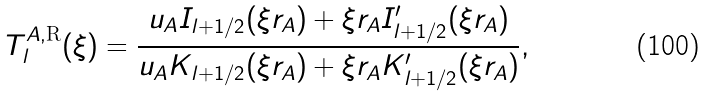Convert formula to latex. <formula><loc_0><loc_0><loc_500><loc_500>T ^ { A , \text {R} } _ { l } ( \xi ) = \frac { u _ { A } I _ { l + 1 / 2 } ( \xi r _ { A } ) + \xi r _ { A } I _ { l + 1 / 2 } ^ { \prime } ( \xi r _ { A } ) } { u _ { A } K _ { l + 1 / 2 } ( \xi r _ { A } ) + \xi r _ { A } K _ { l + 1 / 2 } ^ { \prime } ( \xi r _ { A } ) } ,</formula> 